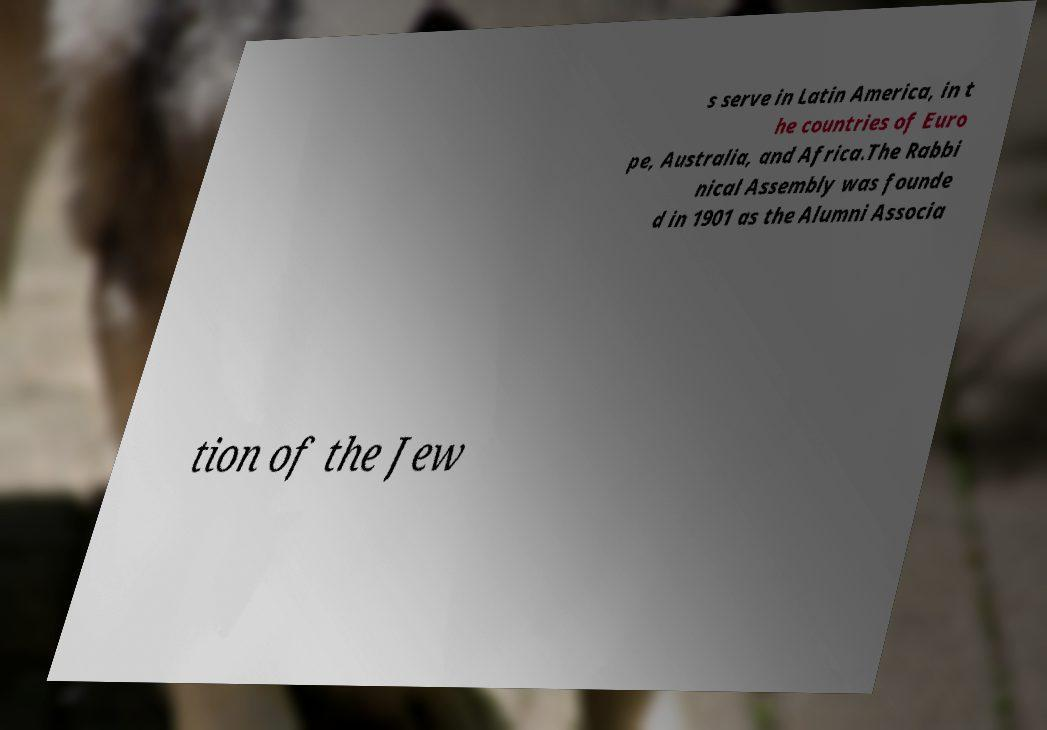Can you read and provide the text displayed in the image?This photo seems to have some interesting text. Can you extract and type it out for me? s serve in Latin America, in t he countries of Euro pe, Australia, and Africa.The Rabbi nical Assembly was founde d in 1901 as the Alumni Associa tion of the Jew 